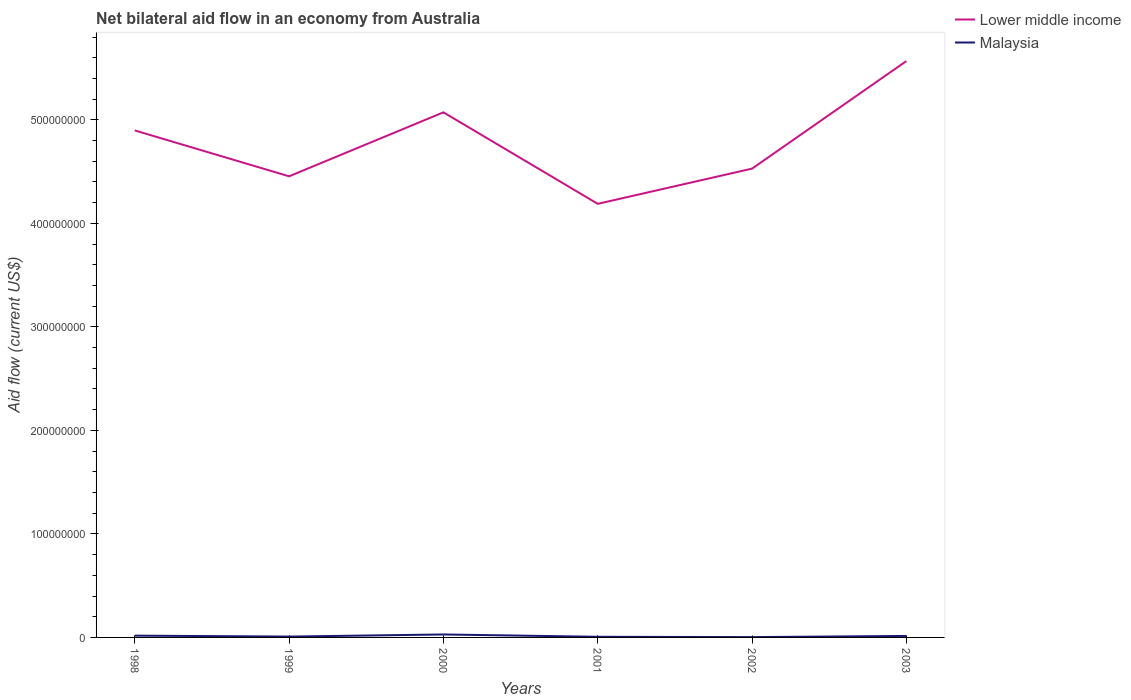Does the line corresponding to Malaysia intersect with the line corresponding to Lower middle income?
Your response must be concise. No. Across all years, what is the maximum net bilateral aid flow in Malaysia?
Provide a succinct answer. 3.00e+05. What is the total net bilateral aid flow in Lower middle income in the graph?
Your answer should be very brief. 8.84e+07. What is the difference between the highest and the second highest net bilateral aid flow in Malaysia?
Offer a terse response. 2.55e+06. What is the difference between the highest and the lowest net bilateral aid flow in Malaysia?
Provide a short and direct response. 3. Does the graph contain any zero values?
Offer a terse response. No. What is the title of the graph?
Make the answer very short. Net bilateral aid flow in an economy from Australia. Does "St. Martin (French part)" appear as one of the legend labels in the graph?
Your answer should be very brief. No. What is the Aid flow (current US$) in Lower middle income in 1998?
Your answer should be compact. 4.90e+08. What is the Aid flow (current US$) of Malaysia in 1998?
Offer a terse response. 1.72e+06. What is the Aid flow (current US$) of Lower middle income in 1999?
Provide a short and direct response. 4.45e+08. What is the Aid flow (current US$) in Malaysia in 1999?
Offer a very short reply. 8.20e+05. What is the Aid flow (current US$) in Lower middle income in 2000?
Keep it short and to the point. 5.07e+08. What is the Aid flow (current US$) in Malaysia in 2000?
Your response must be concise. 2.85e+06. What is the Aid flow (current US$) in Lower middle income in 2001?
Offer a terse response. 4.19e+08. What is the Aid flow (current US$) of Malaysia in 2001?
Provide a succinct answer. 6.30e+05. What is the Aid flow (current US$) in Lower middle income in 2002?
Make the answer very short. 4.53e+08. What is the Aid flow (current US$) of Malaysia in 2002?
Give a very brief answer. 3.00e+05. What is the Aid flow (current US$) in Lower middle income in 2003?
Offer a terse response. 5.57e+08. What is the Aid flow (current US$) of Malaysia in 2003?
Your answer should be very brief. 1.44e+06. Across all years, what is the maximum Aid flow (current US$) of Lower middle income?
Offer a terse response. 5.57e+08. Across all years, what is the maximum Aid flow (current US$) in Malaysia?
Your answer should be compact. 2.85e+06. Across all years, what is the minimum Aid flow (current US$) in Lower middle income?
Your answer should be very brief. 4.19e+08. Across all years, what is the minimum Aid flow (current US$) in Malaysia?
Your response must be concise. 3.00e+05. What is the total Aid flow (current US$) in Lower middle income in the graph?
Offer a terse response. 2.87e+09. What is the total Aid flow (current US$) in Malaysia in the graph?
Give a very brief answer. 7.76e+06. What is the difference between the Aid flow (current US$) in Lower middle income in 1998 and that in 1999?
Your response must be concise. 4.43e+07. What is the difference between the Aid flow (current US$) in Lower middle income in 1998 and that in 2000?
Offer a terse response. -1.75e+07. What is the difference between the Aid flow (current US$) of Malaysia in 1998 and that in 2000?
Provide a succinct answer. -1.13e+06. What is the difference between the Aid flow (current US$) of Lower middle income in 1998 and that in 2001?
Your response must be concise. 7.09e+07. What is the difference between the Aid flow (current US$) of Malaysia in 1998 and that in 2001?
Keep it short and to the point. 1.09e+06. What is the difference between the Aid flow (current US$) of Lower middle income in 1998 and that in 2002?
Provide a succinct answer. 3.69e+07. What is the difference between the Aid flow (current US$) in Malaysia in 1998 and that in 2002?
Your answer should be compact. 1.42e+06. What is the difference between the Aid flow (current US$) of Lower middle income in 1998 and that in 2003?
Your response must be concise. -6.70e+07. What is the difference between the Aid flow (current US$) of Malaysia in 1998 and that in 2003?
Keep it short and to the point. 2.80e+05. What is the difference between the Aid flow (current US$) in Lower middle income in 1999 and that in 2000?
Make the answer very short. -6.18e+07. What is the difference between the Aid flow (current US$) in Malaysia in 1999 and that in 2000?
Ensure brevity in your answer.  -2.03e+06. What is the difference between the Aid flow (current US$) in Lower middle income in 1999 and that in 2001?
Give a very brief answer. 2.66e+07. What is the difference between the Aid flow (current US$) in Lower middle income in 1999 and that in 2002?
Keep it short and to the point. -7.43e+06. What is the difference between the Aid flow (current US$) of Malaysia in 1999 and that in 2002?
Make the answer very short. 5.20e+05. What is the difference between the Aid flow (current US$) in Lower middle income in 1999 and that in 2003?
Provide a succinct answer. -1.11e+08. What is the difference between the Aid flow (current US$) of Malaysia in 1999 and that in 2003?
Your answer should be very brief. -6.20e+05. What is the difference between the Aid flow (current US$) of Lower middle income in 2000 and that in 2001?
Keep it short and to the point. 8.84e+07. What is the difference between the Aid flow (current US$) of Malaysia in 2000 and that in 2001?
Keep it short and to the point. 2.22e+06. What is the difference between the Aid flow (current US$) of Lower middle income in 2000 and that in 2002?
Provide a short and direct response. 5.44e+07. What is the difference between the Aid flow (current US$) in Malaysia in 2000 and that in 2002?
Your response must be concise. 2.55e+06. What is the difference between the Aid flow (current US$) of Lower middle income in 2000 and that in 2003?
Provide a short and direct response. -4.95e+07. What is the difference between the Aid flow (current US$) of Malaysia in 2000 and that in 2003?
Your answer should be compact. 1.41e+06. What is the difference between the Aid flow (current US$) of Lower middle income in 2001 and that in 2002?
Provide a short and direct response. -3.40e+07. What is the difference between the Aid flow (current US$) of Lower middle income in 2001 and that in 2003?
Provide a short and direct response. -1.38e+08. What is the difference between the Aid flow (current US$) of Malaysia in 2001 and that in 2003?
Give a very brief answer. -8.10e+05. What is the difference between the Aid flow (current US$) of Lower middle income in 2002 and that in 2003?
Make the answer very short. -1.04e+08. What is the difference between the Aid flow (current US$) of Malaysia in 2002 and that in 2003?
Offer a very short reply. -1.14e+06. What is the difference between the Aid flow (current US$) of Lower middle income in 1998 and the Aid flow (current US$) of Malaysia in 1999?
Ensure brevity in your answer.  4.89e+08. What is the difference between the Aid flow (current US$) of Lower middle income in 1998 and the Aid flow (current US$) of Malaysia in 2000?
Make the answer very short. 4.87e+08. What is the difference between the Aid flow (current US$) in Lower middle income in 1998 and the Aid flow (current US$) in Malaysia in 2001?
Provide a short and direct response. 4.89e+08. What is the difference between the Aid flow (current US$) in Lower middle income in 1998 and the Aid flow (current US$) in Malaysia in 2002?
Your answer should be compact. 4.89e+08. What is the difference between the Aid flow (current US$) of Lower middle income in 1998 and the Aid flow (current US$) of Malaysia in 2003?
Ensure brevity in your answer.  4.88e+08. What is the difference between the Aid flow (current US$) in Lower middle income in 1999 and the Aid flow (current US$) in Malaysia in 2000?
Offer a very short reply. 4.43e+08. What is the difference between the Aid flow (current US$) in Lower middle income in 1999 and the Aid flow (current US$) in Malaysia in 2001?
Provide a short and direct response. 4.45e+08. What is the difference between the Aid flow (current US$) in Lower middle income in 1999 and the Aid flow (current US$) in Malaysia in 2002?
Keep it short and to the point. 4.45e+08. What is the difference between the Aid flow (current US$) in Lower middle income in 1999 and the Aid flow (current US$) in Malaysia in 2003?
Provide a short and direct response. 4.44e+08. What is the difference between the Aid flow (current US$) of Lower middle income in 2000 and the Aid flow (current US$) of Malaysia in 2001?
Your response must be concise. 5.07e+08. What is the difference between the Aid flow (current US$) of Lower middle income in 2000 and the Aid flow (current US$) of Malaysia in 2002?
Provide a short and direct response. 5.07e+08. What is the difference between the Aid flow (current US$) of Lower middle income in 2000 and the Aid flow (current US$) of Malaysia in 2003?
Give a very brief answer. 5.06e+08. What is the difference between the Aid flow (current US$) in Lower middle income in 2001 and the Aid flow (current US$) in Malaysia in 2002?
Provide a short and direct response. 4.19e+08. What is the difference between the Aid flow (current US$) in Lower middle income in 2001 and the Aid flow (current US$) in Malaysia in 2003?
Provide a succinct answer. 4.17e+08. What is the difference between the Aid flow (current US$) of Lower middle income in 2002 and the Aid flow (current US$) of Malaysia in 2003?
Your response must be concise. 4.51e+08. What is the average Aid flow (current US$) in Lower middle income per year?
Keep it short and to the point. 4.79e+08. What is the average Aid flow (current US$) of Malaysia per year?
Provide a short and direct response. 1.29e+06. In the year 1998, what is the difference between the Aid flow (current US$) of Lower middle income and Aid flow (current US$) of Malaysia?
Give a very brief answer. 4.88e+08. In the year 1999, what is the difference between the Aid flow (current US$) in Lower middle income and Aid flow (current US$) in Malaysia?
Provide a short and direct response. 4.45e+08. In the year 2000, what is the difference between the Aid flow (current US$) of Lower middle income and Aid flow (current US$) of Malaysia?
Ensure brevity in your answer.  5.04e+08. In the year 2001, what is the difference between the Aid flow (current US$) in Lower middle income and Aid flow (current US$) in Malaysia?
Ensure brevity in your answer.  4.18e+08. In the year 2002, what is the difference between the Aid flow (current US$) in Lower middle income and Aid flow (current US$) in Malaysia?
Your response must be concise. 4.53e+08. In the year 2003, what is the difference between the Aid flow (current US$) in Lower middle income and Aid flow (current US$) in Malaysia?
Provide a succinct answer. 5.55e+08. What is the ratio of the Aid flow (current US$) of Lower middle income in 1998 to that in 1999?
Your answer should be compact. 1.1. What is the ratio of the Aid flow (current US$) of Malaysia in 1998 to that in 1999?
Ensure brevity in your answer.  2.1. What is the ratio of the Aid flow (current US$) of Lower middle income in 1998 to that in 2000?
Your answer should be compact. 0.97. What is the ratio of the Aid flow (current US$) of Malaysia in 1998 to that in 2000?
Your response must be concise. 0.6. What is the ratio of the Aid flow (current US$) in Lower middle income in 1998 to that in 2001?
Provide a succinct answer. 1.17. What is the ratio of the Aid flow (current US$) in Malaysia in 1998 to that in 2001?
Your answer should be very brief. 2.73. What is the ratio of the Aid flow (current US$) in Lower middle income in 1998 to that in 2002?
Your answer should be very brief. 1.08. What is the ratio of the Aid flow (current US$) of Malaysia in 1998 to that in 2002?
Keep it short and to the point. 5.73. What is the ratio of the Aid flow (current US$) of Lower middle income in 1998 to that in 2003?
Make the answer very short. 0.88. What is the ratio of the Aid flow (current US$) in Malaysia in 1998 to that in 2003?
Make the answer very short. 1.19. What is the ratio of the Aid flow (current US$) of Lower middle income in 1999 to that in 2000?
Provide a succinct answer. 0.88. What is the ratio of the Aid flow (current US$) in Malaysia in 1999 to that in 2000?
Give a very brief answer. 0.29. What is the ratio of the Aid flow (current US$) of Lower middle income in 1999 to that in 2001?
Offer a very short reply. 1.06. What is the ratio of the Aid flow (current US$) in Malaysia in 1999 to that in 2001?
Make the answer very short. 1.3. What is the ratio of the Aid flow (current US$) of Lower middle income in 1999 to that in 2002?
Keep it short and to the point. 0.98. What is the ratio of the Aid flow (current US$) in Malaysia in 1999 to that in 2002?
Make the answer very short. 2.73. What is the ratio of the Aid flow (current US$) of Lower middle income in 1999 to that in 2003?
Make the answer very short. 0.8. What is the ratio of the Aid flow (current US$) of Malaysia in 1999 to that in 2003?
Give a very brief answer. 0.57. What is the ratio of the Aid flow (current US$) in Lower middle income in 2000 to that in 2001?
Offer a terse response. 1.21. What is the ratio of the Aid flow (current US$) in Malaysia in 2000 to that in 2001?
Give a very brief answer. 4.52. What is the ratio of the Aid flow (current US$) in Lower middle income in 2000 to that in 2002?
Offer a very short reply. 1.12. What is the ratio of the Aid flow (current US$) of Malaysia in 2000 to that in 2002?
Provide a succinct answer. 9.5. What is the ratio of the Aid flow (current US$) of Lower middle income in 2000 to that in 2003?
Provide a short and direct response. 0.91. What is the ratio of the Aid flow (current US$) of Malaysia in 2000 to that in 2003?
Make the answer very short. 1.98. What is the ratio of the Aid flow (current US$) in Lower middle income in 2001 to that in 2002?
Offer a terse response. 0.92. What is the ratio of the Aid flow (current US$) in Lower middle income in 2001 to that in 2003?
Offer a terse response. 0.75. What is the ratio of the Aid flow (current US$) in Malaysia in 2001 to that in 2003?
Ensure brevity in your answer.  0.44. What is the ratio of the Aid flow (current US$) of Lower middle income in 2002 to that in 2003?
Ensure brevity in your answer.  0.81. What is the ratio of the Aid flow (current US$) in Malaysia in 2002 to that in 2003?
Your response must be concise. 0.21. What is the difference between the highest and the second highest Aid flow (current US$) in Lower middle income?
Ensure brevity in your answer.  4.95e+07. What is the difference between the highest and the second highest Aid flow (current US$) of Malaysia?
Your answer should be very brief. 1.13e+06. What is the difference between the highest and the lowest Aid flow (current US$) in Lower middle income?
Your answer should be compact. 1.38e+08. What is the difference between the highest and the lowest Aid flow (current US$) of Malaysia?
Offer a terse response. 2.55e+06. 